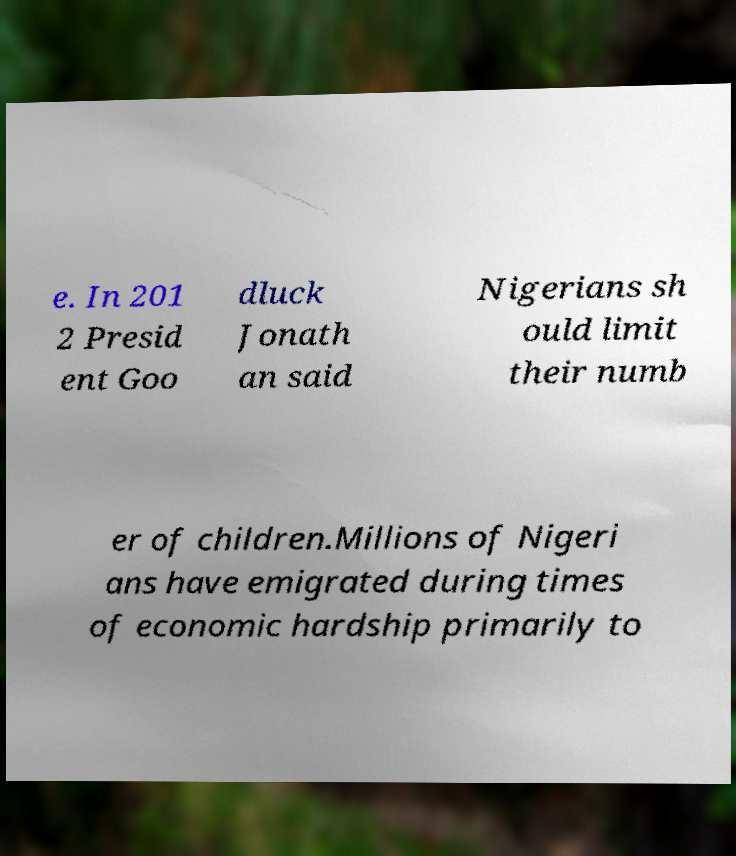Could you extract and type out the text from this image? e. In 201 2 Presid ent Goo dluck Jonath an said Nigerians sh ould limit their numb er of children.Millions of Nigeri ans have emigrated during times of economic hardship primarily to 